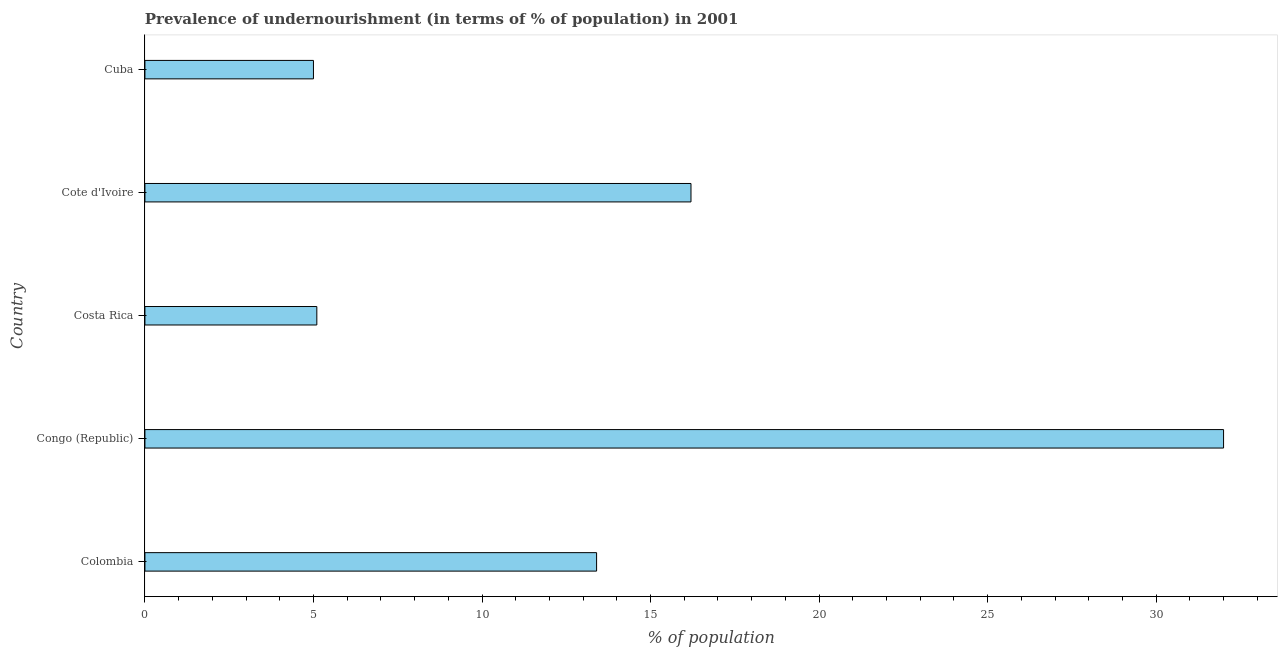Does the graph contain any zero values?
Give a very brief answer. No. What is the title of the graph?
Offer a very short reply. Prevalence of undernourishment (in terms of % of population) in 2001. What is the label or title of the X-axis?
Make the answer very short. % of population. What is the percentage of undernourished population in Congo (Republic)?
Give a very brief answer. 32. Across all countries, what is the maximum percentage of undernourished population?
Make the answer very short. 32. In which country was the percentage of undernourished population maximum?
Your response must be concise. Congo (Republic). In which country was the percentage of undernourished population minimum?
Offer a terse response. Cuba. What is the sum of the percentage of undernourished population?
Your response must be concise. 71.7. What is the difference between the percentage of undernourished population in Costa Rica and Cuba?
Give a very brief answer. 0.1. What is the average percentage of undernourished population per country?
Keep it short and to the point. 14.34. What is the ratio of the percentage of undernourished population in Colombia to that in Costa Rica?
Offer a terse response. 2.63. What is the difference between the highest and the second highest percentage of undernourished population?
Your response must be concise. 15.8. How many bars are there?
Provide a succinct answer. 5. How many countries are there in the graph?
Keep it short and to the point. 5. What is the difference between two consecutive major ticks on the X-axis?
Make the answer very short. 5. Are the values on the major ticks of X-axis written in scientific E-notation?
Offer a terse response. No. What is the % of population of Congo (Republic)?
Offer a very short reply. 32. What is the % of population in Cote d'Ivoire?
Your answer should be compact. 16.2. What is the difference between the % of population in Colombia and Congo (Republic)?
Make the answer very short. -18.6. What is the difference between the % of population in Colombia and Cuba?
Provide a short and direct response. 8.4. What is the difference between the % of population in Congo (Republic) and Costa Rica?
Keep it short and to the point. 26.9. What is the ratio of the % of population in Colombia to that in Congo (Republic)?
Your answer should be compact. 0.42. What is the ratio of the % of population in Colombia to that in Costa Rica?
Ensure brevity in your answer.  2.63. What is the ratio of the % of population in Colombia to that in Cote d'Ivoire?
Make the answer very short. 0.83. What is the ratio of the % of population in Colombia to that in Cuba?
Your response must be concise. 2.68. What is the ratio of the % of population in Congo (Republic) to that in Costa Rica?
Your answer should be compact. 6.28. What is the ratio of the % of population in Congo (Republic) to that in Cote d'Ivoire?
Your response must be concise. 1.98. What is the ratio of the % of population in Costa Rica to that in Cote d'Ivoire?
Provide a succinct answer. 0.32. What is the ratio of the % of population in Cote d'Ivoire to that in Cuba?
Offer a terse response. 3.24. 